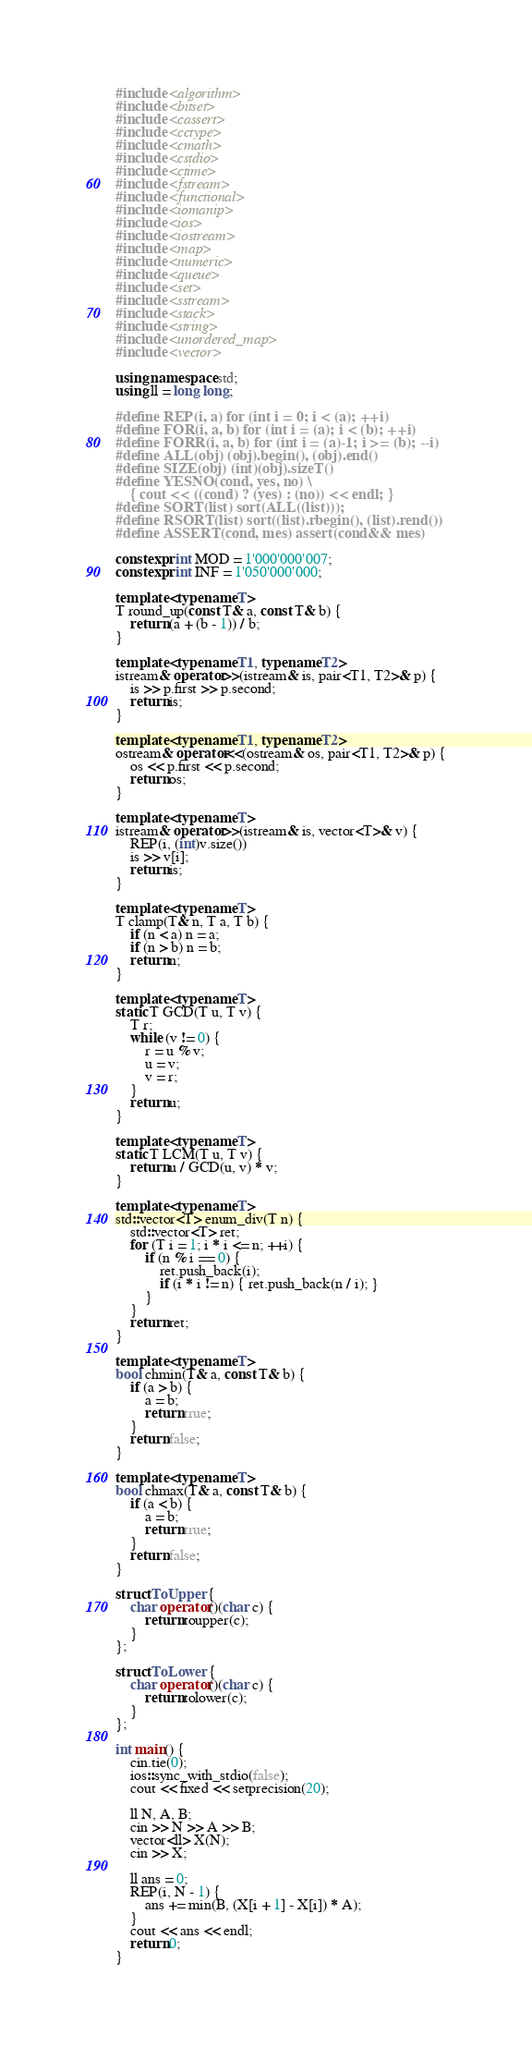Convert code to text. <code><loc_0><loc_0><loc_500><loc_500><_C++_>#include <algorithm>
#include <bitset>
#include <cassert>
#include <cctype>
#include <cmath>
#include <cstdio>
#include <ctime>
#include <fstream>
#include <functional>
#include <iomanip>
#include <ios>
#include <iostream>
#include <map>
#include <numeric>
#include <queue>
#include <set>
#include <sstream>
#include <stack>
#include <string>
#include <unordered_map>
#include <vector>

using namespace std;
using ll = long long;

#define REP(i, a) for (int i = 0; i < (a); ++i)
#define FOR(i, a, b) for (int i = (a); i < (b); ++i)
#define FORR(i, a, b) for (int i = (a)-1; i >= (b); --i)
#define ALL(obj) (obj).begin(), (obj).end()
#define SIZE(obj) (int)(obj).sizeT()
#define YESNO(cond, yes, no) \
    { cout << ((cond) ? (yes) : (no)) << endl; }
#define SORT(list) sort(ALL((list)));
#define RSORT(list) sort((list).rbegin(), (list).rend())
#define ASSERT(cond, mes) assert(cond&& mes)

constexpr int MOD = 1'000'000'007;
constexpr int INF = 1'050'000'000;

template <typename T>
T round_up(const T& a, const T& b) {
    return (a + (b - 1)) / b;
}

template <typename T1, typename T2>
istream& operator>>(istream& is, pair<T1, T2>& p) {
    is >> p.first >> p.second;
    return is;
}

template <typename T1, typename T2>
ostream& operator<<(ostream& os, pair<T1, T2>& p) {
    os << p.first << p.second;
    return os;
}

template <typename T>
istream& operator>>(istream& is, vector<T>& v) {
    REP(i, (int)v.size())
    is >> v[i];
    return is;
}

template <typename T>
T clamp(T& n, T a, T b) {
    if (n < a) n = a;
    if (n > b) n = b;
    return n;
}

template <typename T>
static T GCD(T u, T v) {
    T r;
    while (v != 0) {
        r = u % v;
        u = v;
        v = r;
    }
    return u;
}

template <typename T>
static T LCM(T u, T v) {
    return u / GCD(u, v) * v;
}

template <typename T>
std::vector<T> enum_div(T n) {
    std::vector<T> ret;
    for (T i = 1; i * i <= n; ++i) {
        if (n % i == 0) {
            ret.push_back(i);
            if (i * i != n) { ret.push_back(n / i); }
        }
    }
    return ret;
}

template <typename T>
bool chmin(T& a, const T& b) {
    if (a > b) {
        a = b;
        return true;
    }
    return false;
}

template <typename T>
bool chmax(T& a, const T& b) {
    if (a < b) {
        a = b;
        return true;
    }
    return false;
}

struct ToUpper {
    char operator()(char c) {
        return toupper(c);
    }
};

struct ToLower {
    char operator()(char c) {
        return tolower(c);
    }
};

int main() {
    cin.tie(0);
    ios::sync_with_stdio(false);
    cout << fixed << setprecision(20);

    ll N, A, B;
    cin >> N >> A >> B;
    vector<ll> X(N);
    cin >> X;

    ll ans = 0;
    REP(i, N - 1) {
        ans += min(B, (X[i + 1] - X[i]) * A);
    }
    cout << ans << endl;
    return 0;
}</code> 